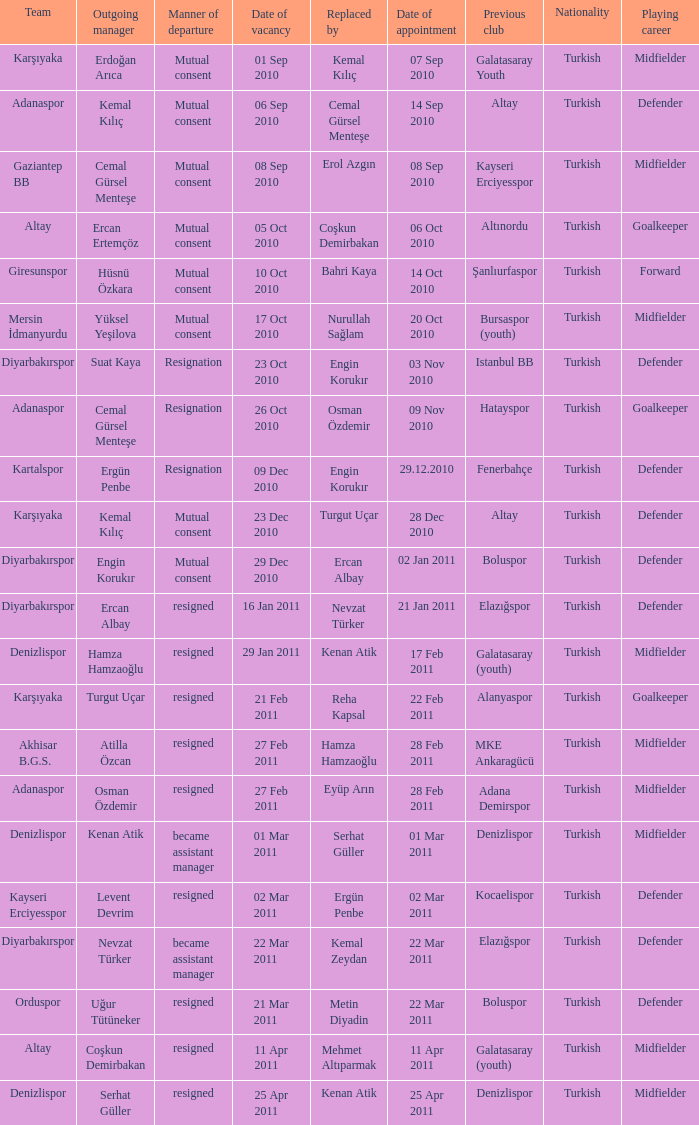Who replaced the manager of Akhisar B.G.S.? Hamza Hamzaoğlu. 